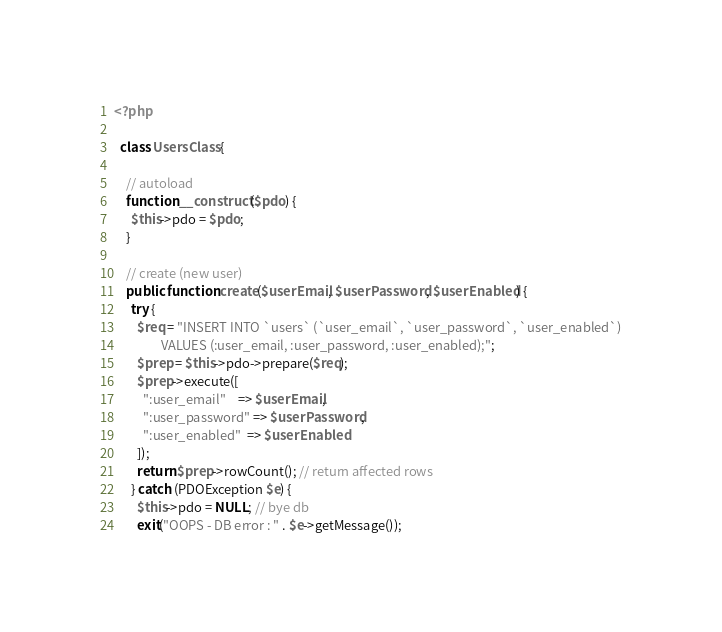<code> <loc_0><loc_0><loc_500><loc_500><_PHP_><?php

  class UsersClass {

    // autoload
    function __construct($pdo) {
      $this->pdo = $pdo;
    }

    // create (new user)
    public function create($userEmail, $userPassword, $userEnabled) {
      try {
        $req = "INSERT INTO `users` (`user_email`, `user_password`, `user_enabled`)
                VALUES (:user_email, :user_password, :user_enabled);";
        $prep = $this->pdo->prepare($req);
        $prep->execute([
          ":user_email"    => $userEmail,
          ":user_password" => $userPassword,
          ":user_enabled"  => $userEnabled
        ]);
        return $prep->rowCount(); // return affected rows
      } catch (PDOException $e) {
        $this->pdo = NULL; // bye db
        exit("OOPS - DB error : " . $e->getMessage());</code> 